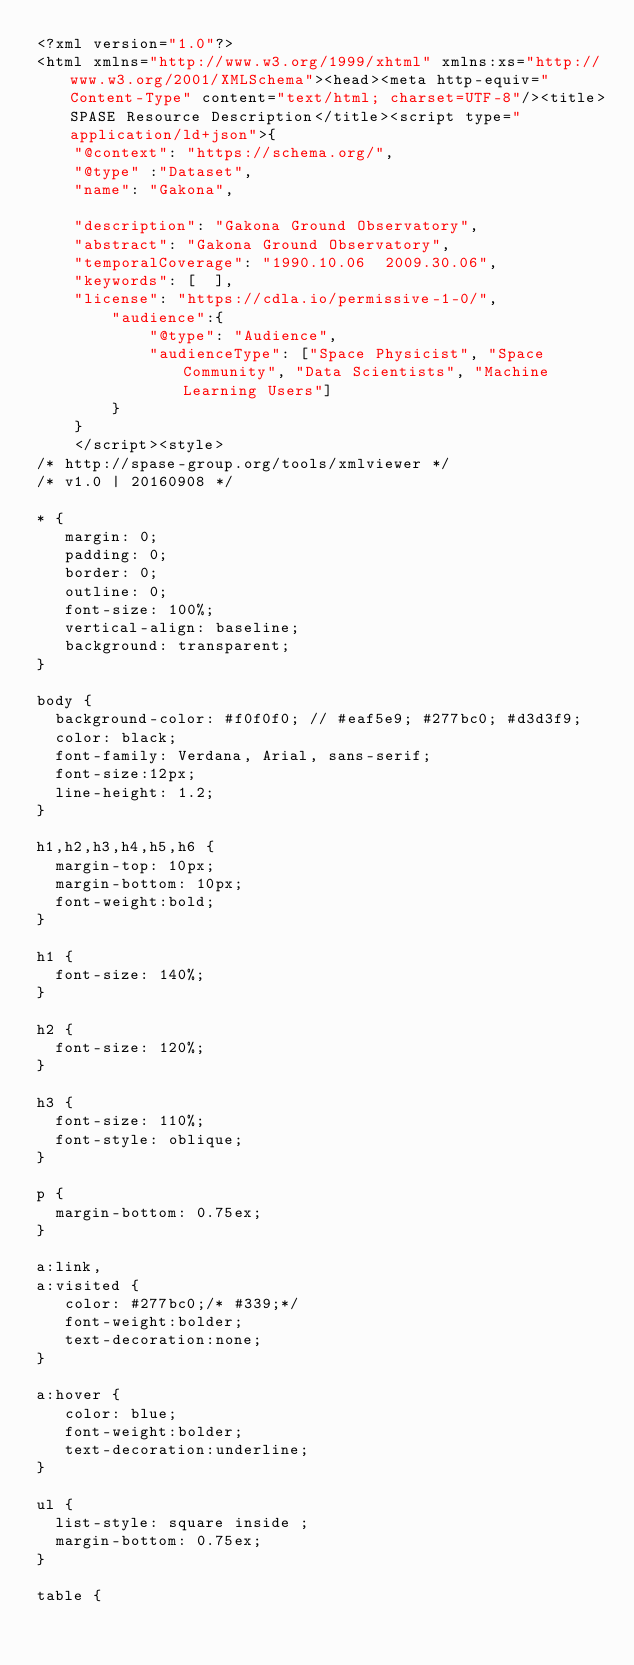Convert code to text. <code><loc_0><loc_0><loc_500><loc_500><_HTML_><?xml version="1.0"?>
<html xmlns="http://www.w3.org/1999/xhtml" xmlns:xs="http://www.w3.org/2001/XMLSchema"><head><meta http-equiv="Content-Type" content="text/html; charset=UTF-8"/><title>SPASE Resource Description</title><script type="application/ld+json">{
		"@context": "https://schema.org/",
		"@type" :"Dataset",
		"name": "Gakona",
     
 		"description": "Gakona Ground Observatory",
		"abstract": "Gakona Ground Observatory",
		"temporalCoverage": "1990.10.06  2009.30.06",
		"keywords": [  ],
		"license": "https://cdla.io/permissive-1-0/",
        "audience":{
            "@type": "Audience",
            "audienceType": ["Space Physicist", "Space Community", "Data Scientists", "Machine Learning Users"]
        }
	  }
	  </script><style>
/* http://spase-group.org/tools/xmlviewer */
/* v1.0 | 20160908 */

* {
   margin: 0;
   padding: 0;
   border: 0;
   outline: 0;
   font-size: 100%;
   vertical-align: baseline;
   background: transparent;
}

body {
	background-color: #f0f0f0; // #eaf5e9; #277bc0; #d3d3f9;
	color: black;
	font-family: Verdana, Arial, sans-serif; 
	font-size:12px; 
	line-height: 1.2;
}
 
h1,h2,h3,h4,h5,h6 {
	margin-top: 10px;
	margin-bottom: 10px;
	font-weight:bold;
}

h1 {
	font-size: 140%;
}

h2 {
	font-size: 120%;
}

h3 {
	font-size: 110%;
	font-style: oblique;
}

p {
	margin-bottom: 0.75ex;
}

a:link,
a:visited {
   color: #277bc0;/* #339;*/
   font-weight:bolder; 
   text-decoration:none; 
}

a:hover {
   color: blue;
   font-weight:bolder; 
   text-decoration:underline; 
}

ul {
	list-style: square inside ;
	margin-bottom: 0.75ex;
}

table {</code> 